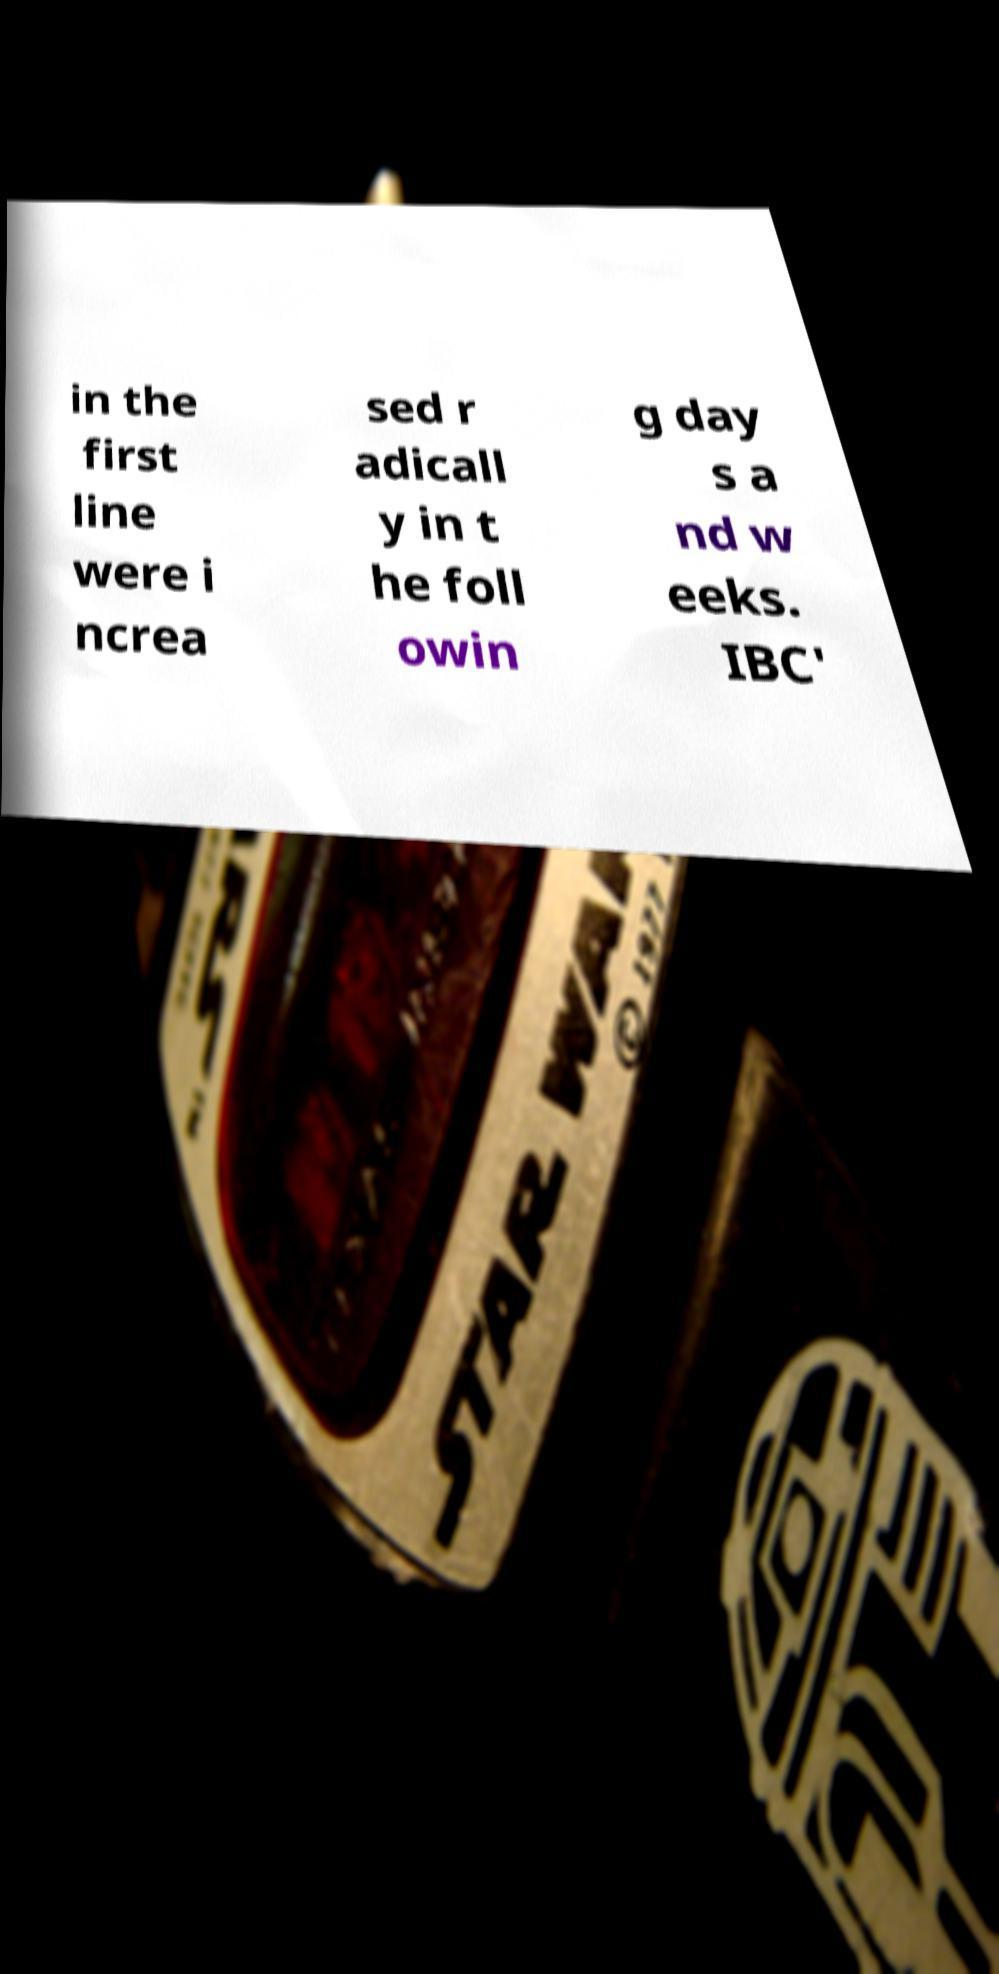I need the written content from this picture converted into text. Can you do that? in the first line were i ncrea sed r adicall y in t he foll owin g day s a nd w eeks. IBC' 